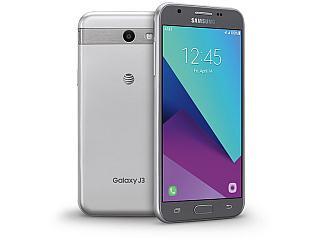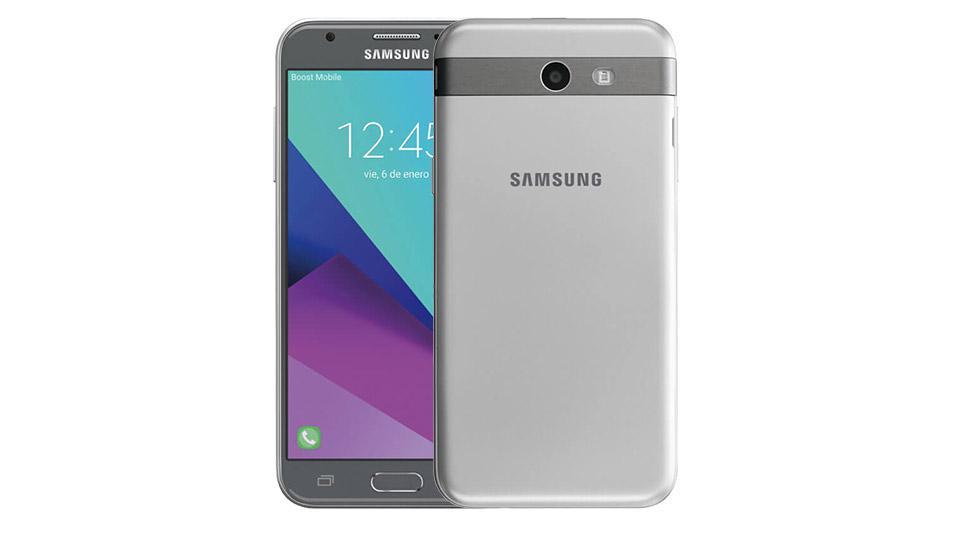The first image is the image on the left, the second image is the image on the right. Given the left and right images, does the statement "All phones are shown upright, and none of them have physical keyboards." hold true? Answer yes or no. Yes. The first image is the image on the left, the second image is the image on the right. Examine the images to the left and right. Is the description "All devices are rectangular and displayed vertically, and at least one device has geometric shapes of different colors filling its screen." accurate? Answer yes or no. Yes. 